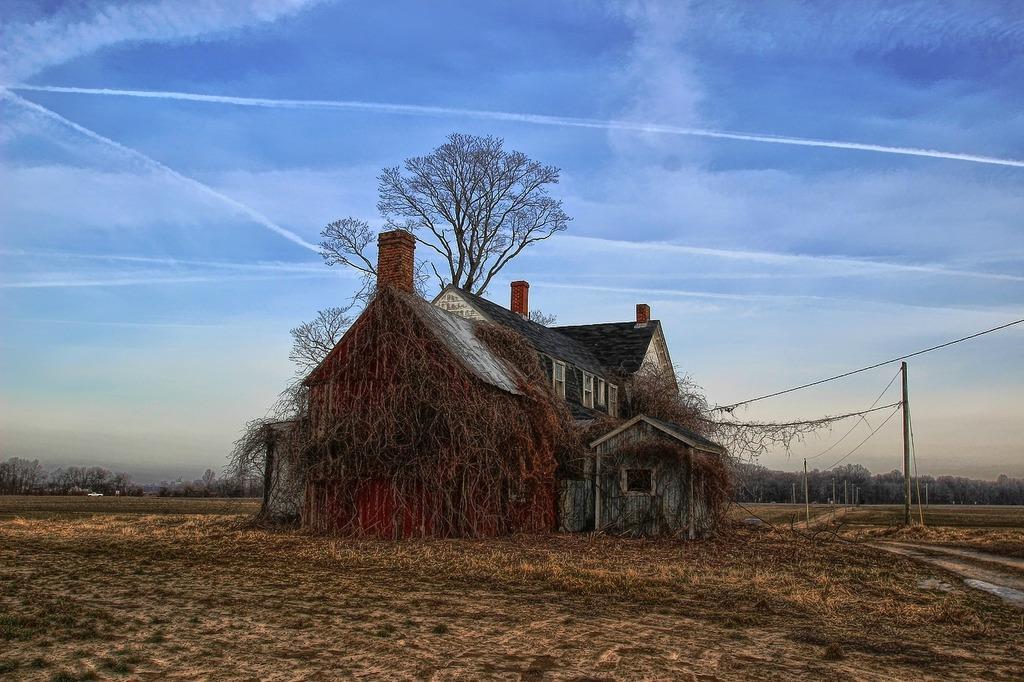Please provide a concise description of this image. In the middle of the picture, we see the building in white color with a grey color roof. This building is covered with creeper plants. Behind that, there are trees. At the bottom, we see the grass. On the right side, we see poles and wires. There are trees in the background. At the top, we see the sky, which is blue in color. 